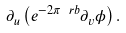<formula> <loc_0><loc_0><loc_500><loc_500>\partial _ { u } \left ( e ^ { - 2 \pi _ { \ } r b } \partial _ { v } \phi \right ) .</formula> 